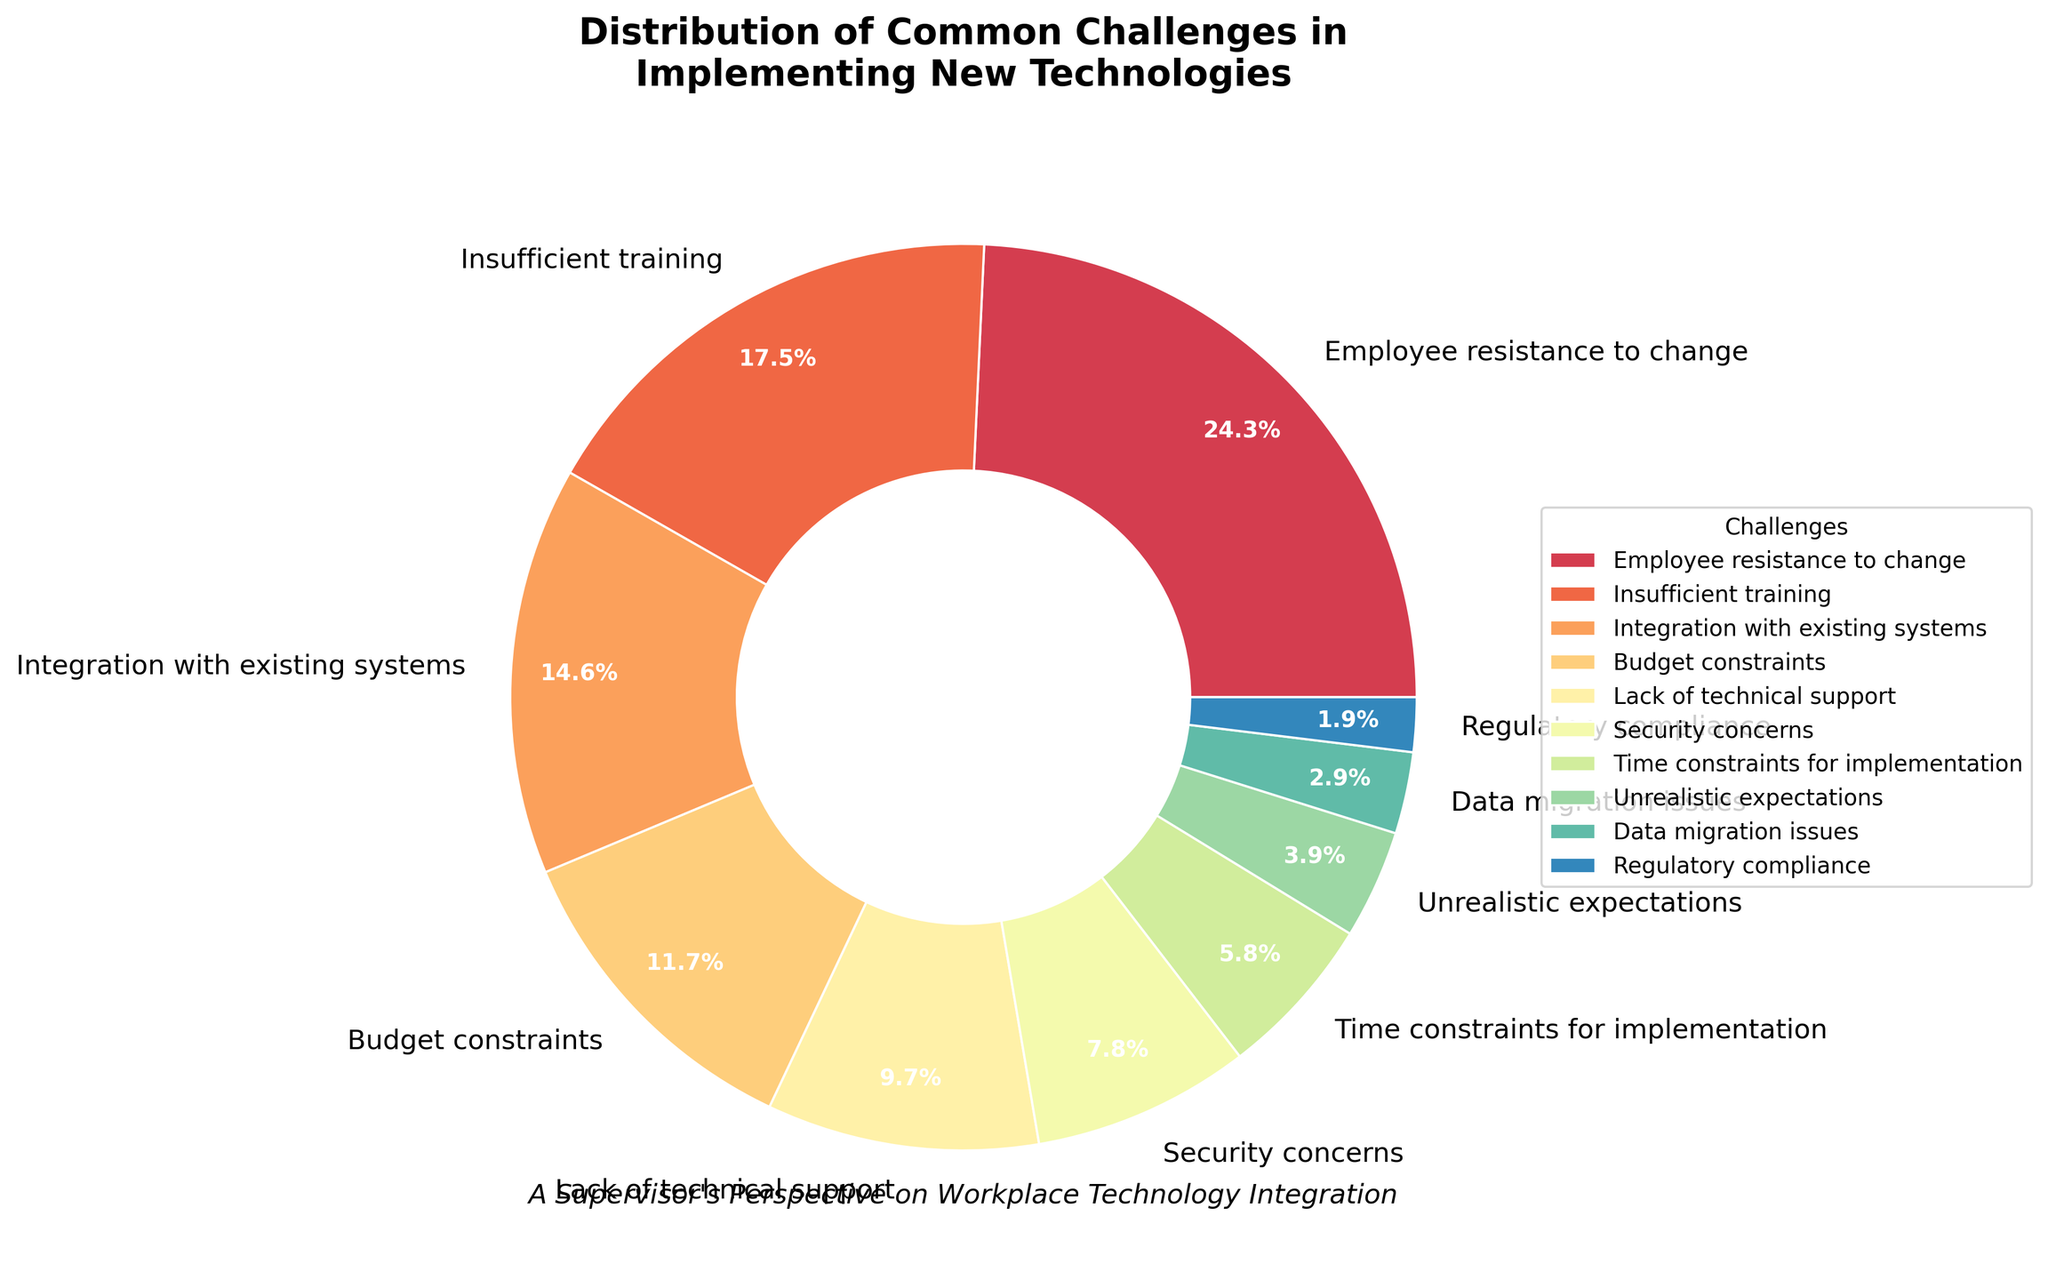What is the most common challenge in implementing new technologies in the workplace? The segment representing "Employee resistance to change" is the largest, with a percentage of 25%, indicating it as the most common challenge.
Answer: Employee resistance to change Which challenge has the smallest percentage? The smallest segment is labeled "Regulatory compliance," which has a percentage of 2%.
Answer: Regulatory compliance What is the combined percentage of "Security concerns" and "Data migration issues"? The segment for "Security concerns" is 8% and "Data migration issues" is 3%. Summing them gives 8% + 3% = 11%.
Answer: 11% How does "Integration with existing systems" compare with "Budget constraints"? The segment for "Integration with existing systems" is 15% and "Budget constraints" is 12%. Therefore, "Integration with existing systems" is larger.
Answer: Integration with existing systems What is the difference in percentage between "Insufficient training" and "Unrealistic expectations"? The segment for "Insufficient training" is 18% and "Unrealistic expectations" is 4%. The difference is 18% - 4% = 14%.
Answer: 14% Which challenges collectively account for more than 50% of the total? The largest segments are "Employee resistance to change" (25%), "Insufficient training" (18%), and "Integration with existing systems" (15%). Summing them gives 25% + 18% + 15% = 58%, which is more than 50%.
Answer: Employee resistance to change, Insufficient training, Integration with existing systems What is the combined percentage of challenges with a value of 10% or less? The segments with 10% or less are "Lack of technical support" (10%), "Security concerns" (8%), "Time constraints for implementation" (6%), "Unrealistic expectations" (4%), "Data migration issues" (3%), and "Regulatory compliance" (2%). Summing them gives 10% + 8% + 6% + 4% + 3% + 2% = 33%.
Answer: 33% Which challenge is represented by the segment with a light green color? Visual assessment of the colors shows that the light green segment corresponds to "Time constraints for implementation," which has a percentage of 6%.
Answer: Time constraints for implementation How many challenges have a percentage greater than 10%? Counting segments greater than 10%, we have "Employee resistance to change" (25%), "Insufficient training" (18%), "Integration with existing systems" (15%), and "Budget constraints" (12%). This gives a total of 4 challenges.
Answer: 4 